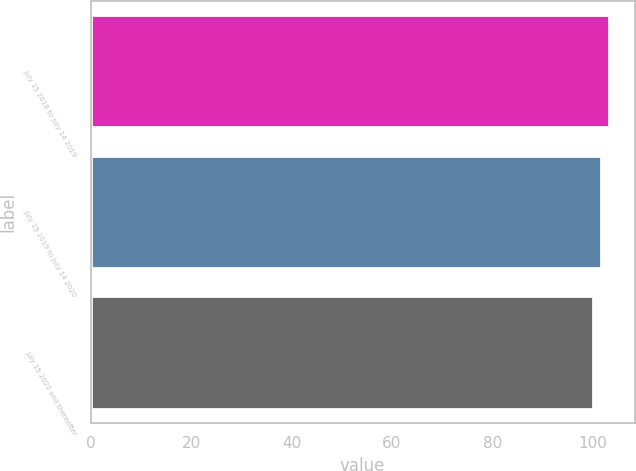<chart> <loc_0><loc_0><loc_500><loc_500><bar_chart><fcel>July 15 2018 to July 14 2019<fcel>July 15 2019 to July 14 2020<fcel>July 15 2020 and thereafter<nl><fcel>103.12<fcel>101.56<fcel>100<nl></chart> 